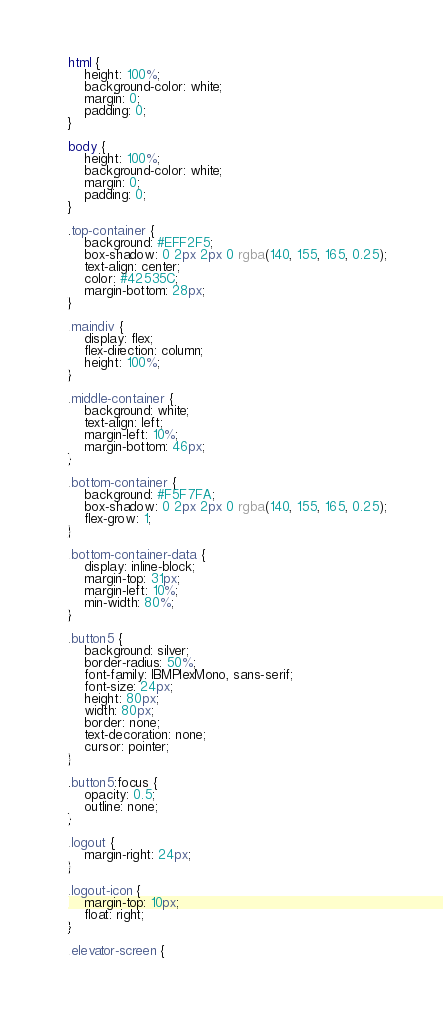<code> <loc_0><loc_0><loc_500><loc_500><_CSS_>html {
    height: 100%;
    background-color: white;
    margin: 0;
    padding: 0;
}

body {
    height: 100%;
    background-color: white;
    margin: 0;
    padding: 0;
}

.top-container {
    background: #EFF2F5;
    box-shadow: 0 2px 2px 0 rgba(140, 155, 165, 0.25);
    text-align: center;
    color: #42535C;
    margin-bottom: 28px;
}

.maindiv {
    display: flex;
    flex-direction: column;
    height: 100%;
}

.middle-container {
    background: white;
    text-align: left;
    margin-left: 10%;
    margin-bottom: 46px;
}

.bottom-container {
    background: #F5F7FA;
    box-shadow: 0 2px 2px 0 rgba(140, 155, 165, 0.25);
    flex-grow: 1;
}

.bottom-container-data {
    display: inline-block;
    margin-top: 31px;
    margin-left: 10%;
    min-width: 80%;
}

.button5 {
    background: silver;
    border-radius: 50%;
    font-family: IBMPlexMono, sans-serif;
    font-size: 24px;
    height: 80px;
    width: 80px;
    border: none;
    text-decoration: none;
    cursor: pointer;
}

.button5:focus {
    opacity: 0.5;
    outline: none;
}

.logout {
    margin-right: 24px;
}

.logout-icon {
    margin-top: 10px;
    float: right;
}

.elevator-screen {</code> 